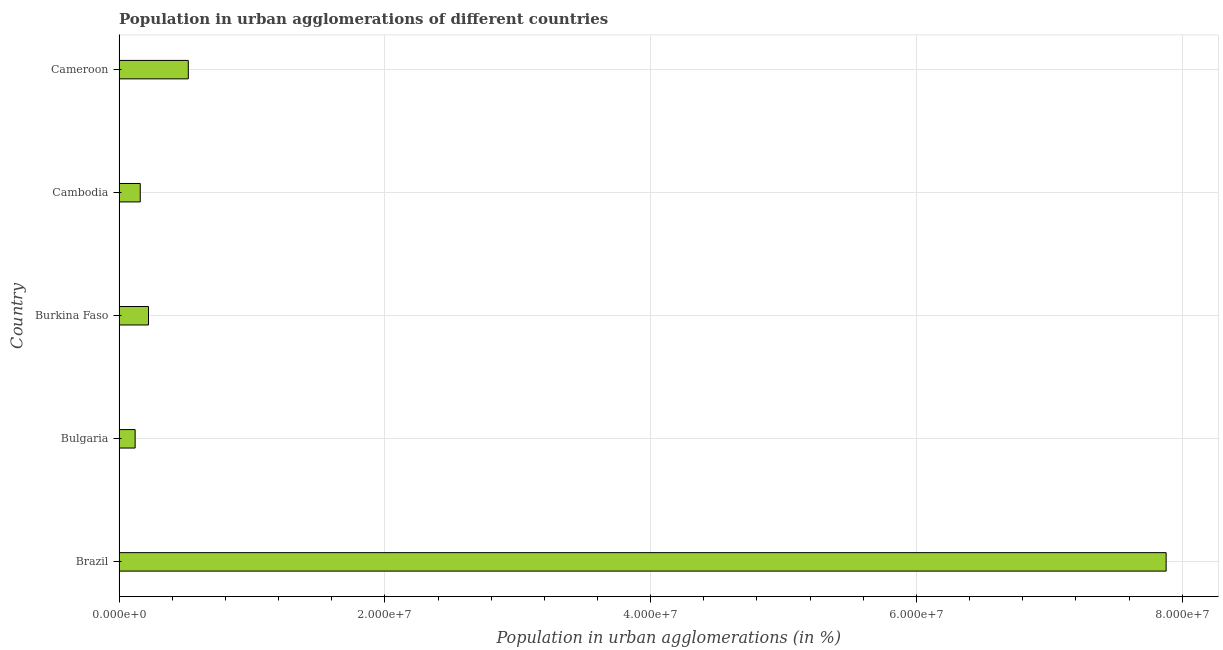What is the title of the graph?
Your answer should be compact. Population in urban agglomerations of different countries. What is the label or title of the X-axis?
Ensure brevity in your answer.  Population in urban agglomerations (in %). What is the population in urban agglomerations in Burkina Faso?
Keep it short and to the point. 2.22e+06. Across all countries, what is the maximum population in urban agglomerations?
Offer a terse response. 7.88e+07. Across all countries, what is the minimum population in urban agglomerations?
Your answer should be compact. 1.21e+06. What is the sum of the population in urban agglomerations?
Make the answer very short. 8.90e+07. What is the difference between the population in urban agglomerations in Bulgaria and Cameroon?
Ensure brevity in your answer.  -4.00e+06. What is the average population in urban agglomerations per country?
Provide a short and direct response. 1.78e+07. What is the median population in urban agglomerations?
Provide a succinct answer. 2.22e+06. In how many countries, is the population in urban agglomerations greater than 52000000 %?
Provide a short and direct response. 1. What is the ratio of the population in urban agglomerations in Brazil to that in Cameroon?
Keep it short and to the point. 15.12. What is the difference between the highest and the second highest population in urban agglomerations?
Provide a short and direct response. 7.36e+07. Is the sum of the population in urban agglomerations in Brazil and Cambodia greater than the maximum population in urban agglomerations across all countries?
Give a very brief answer. Yes. What is the difference between the highest and the lowest population in urban agglomerations?
Your answer should be compact. 7.76e+07. How many bars are there?
Ensure brevity in your answer.  5. What is the Population in urban agglomerations (in %) of Brazil?
Your response must be concise. 7.88e+07. What is the Population in urban agglomerations (in %) of Bulgaria?
Give a very brief answer. 1.21e+06. What is the Population in urban agglomerations (in %) in Burkina Faso?
Keep it short and to the point. 2.22e+06. What is the Population in urban agglomerations (in %) in Cambodia?
Offer a very short reply. 1.59e+06. What is the Population in urban agglomerations (in %) in Cameroon?
Provide a succinct answer. 5.21e+06. What is the difference between the Population in urban agglomerations (in %) in Brazil and Bulgaria?
Provide a succinct answer. 7.76e+07. What is the difference between the Population in urban agglomerations (in %) in Brazil and Burkina Faso?
Provide a short and direct response. 7.66e+07. What is the difference between the Population in urban agglomerations (in %) in Brazil and Cambodia?
Offer a very short reply. 7.72e+07. What is the difference between the Population in urban agglomerations (in %) in Brazil and Cameroon?
Your answer should be very brief. 7.36e+07. What is the difference between the Population in urban agglomerations (in %) in Bulgaria and Burkina Faso?
Keep it short and to the point. -1.01e+06. What is the difference between the Population in urban agglomerations (in %) in Bulgaria and Cambodia?
Make the answer very short. -3.84e+05. What is the difference between the Population in urban agglomerations (in %) in Bulgaria and Cameroon?
Give a very brief answer. -4.00e+06. What is the difference between the Population in urban agglomerations (in %) in Burkina Faso and Cambodia?
Keep it short and to the point. 6.21e+05. What is the difference between the Population in urban agglomerations (in %) in Burkina Faso and Cameroon?
Offer a terse response. -3.00e+06. What is the difference between the Population in urban agglomerations (in %) in Cambodia and Cameroon?
Your answer should be very brief. -3.62e+06. What is the ratio of the Population in urban agglomerations (in %) in Brazil to that in Bulgaria?
Your answer should be compact. 65.08. What is the ratio of the Population in urban agglomerations (in %) in Brazil to that in Burkina Faso?
Your answer should be compact. 35.56. What is the ratio of the Population in urban agglomerations (in %) in Brazil to that in Cambodia?
Provide a short and direct response. 49.41. What is the ratio of the Population in urban agglomerations (in %) in Brazil to that in Cameroon?
Provide a short and direct response. 15.12. What is the ratio of the Population in urban agglomerations (in %) in Bulgaria to that in Burkina Faso?
Keep it short and to the point. 0.55. What is the ratio of the Population in urban agglomerations (in %) in Bulgaria to that in Cambodia?
Keep it short and to the point. 0.76. What is the ratio of the Population in urban agglomerations (in %) in Bulgaria to that in Cameroon?
Give a very brief answer. 0.23. What is the ratio of the Population in urban agglomerations (in %) in Burkina Faso to that in Cambodia?
Offer a very short reply. 1.39. What is the ratio of the Population in urban agglomerations (in %) in Burkina Faso to that in Cameroon?
Provide a succinct answer. 0.42. What is the ratio of the Population in urban agglomerations (in %) in Cambodia to that in Cameroon?
Offer a very short reply. 0.31. 